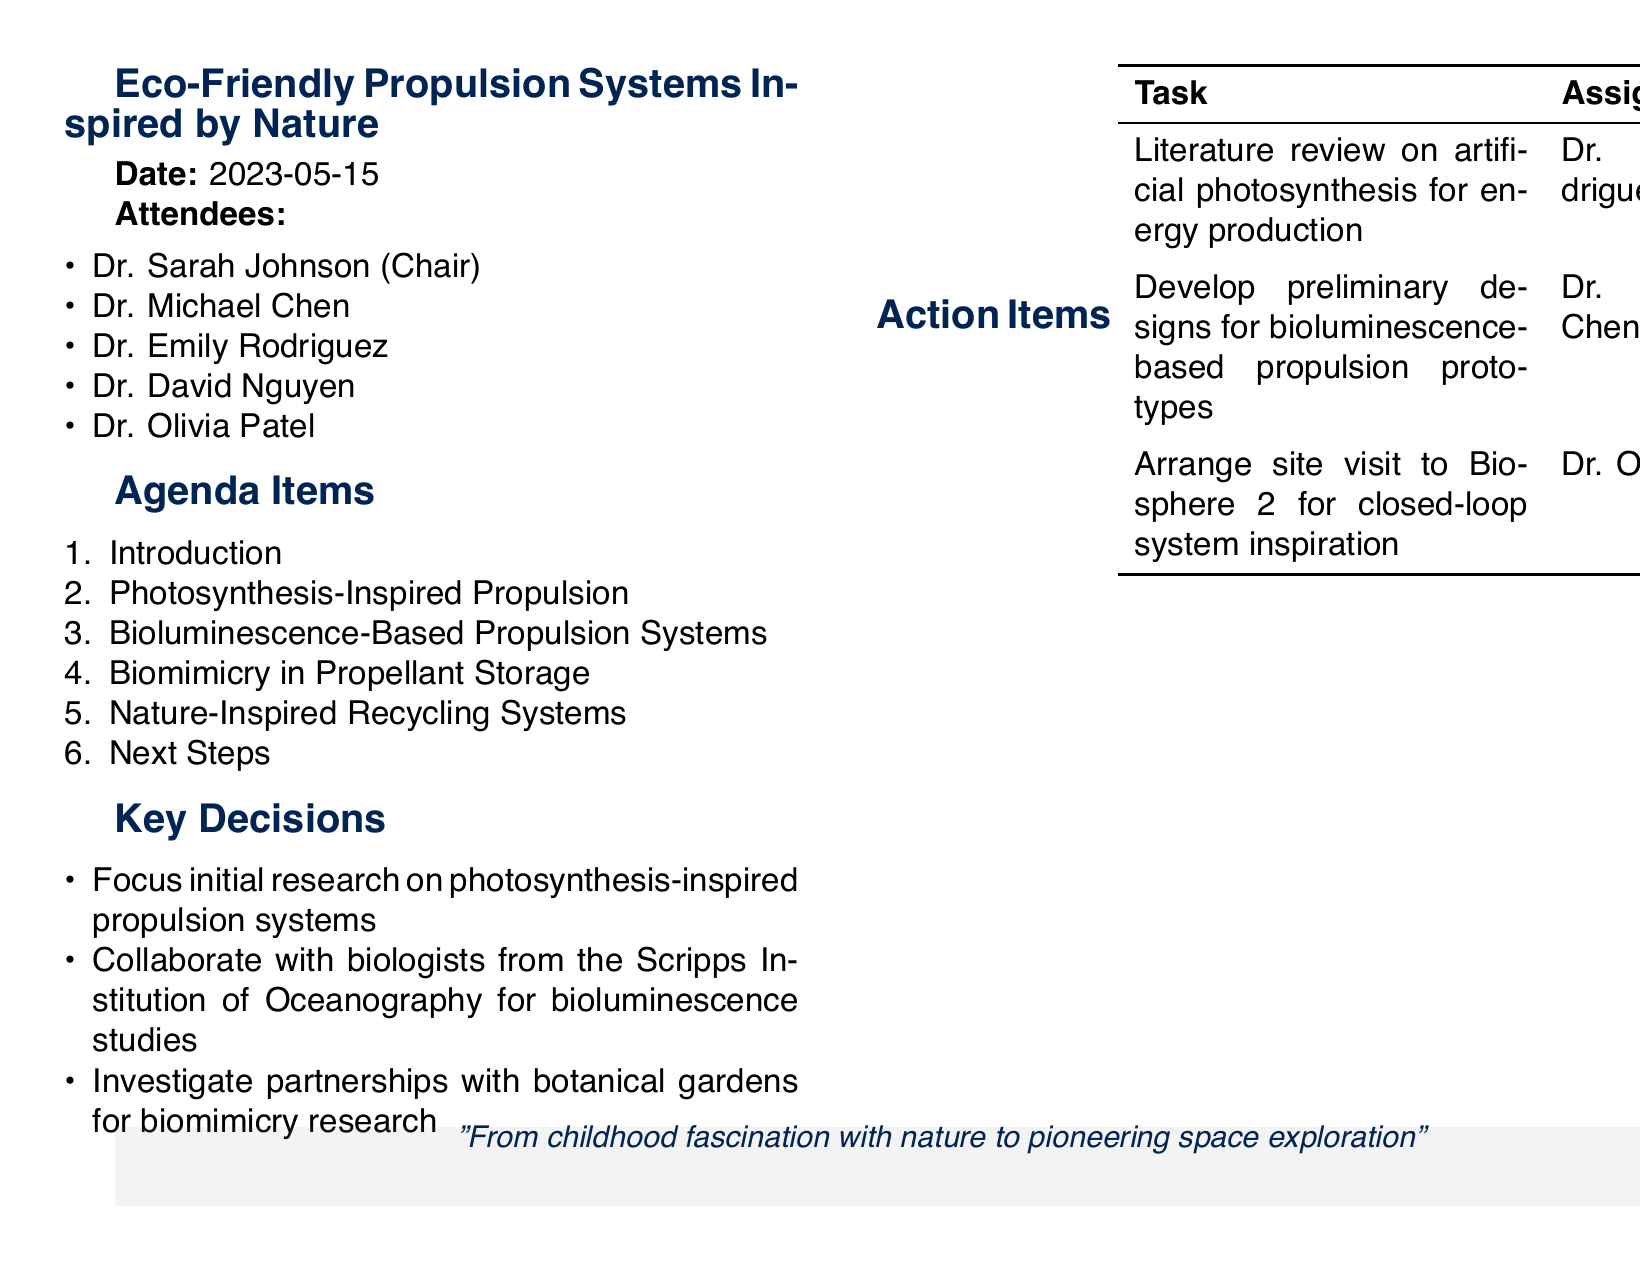What is the date of the meeting? The date of the meeting is provided in the document as a specific date.
Answer: 2023-05-15 Who is the chair of the meeting? The chair is the person listed at the beginning of the attendees list, which indicates their role.
Answer: Dr. Sarah Johnson What is the first agenda item? The agenda items are listed in order, allowing us to identify the first one.
Answer: Introduction What is one key decision made during the meeting? Key decisions are stated clearly in a list, allowing for specific selection.
Answer: Focus initial research on photosynthesis-inspired propulsion systems Who is assigned to develop preliminary designs for bioluminescence-based propulsion prototypes? The action items list includes the assignee for this specific task.
Answer: Dr. Michael Chen How many attendees were present at the meeting? The number of attendees is determined by counting the individuals listed in the attendees section.
Answer: 5 What is the due date for the literature review task? The due date is specified clearly next to the assigned task in the action items.
Answer: 2023-06-15 What inspired the nature-inspired recycling systems discussed in the meeting? This information is found in the agenda items section, which explains the inspiration sources.
Answer: Natural nutrient cycles in ecosystems 